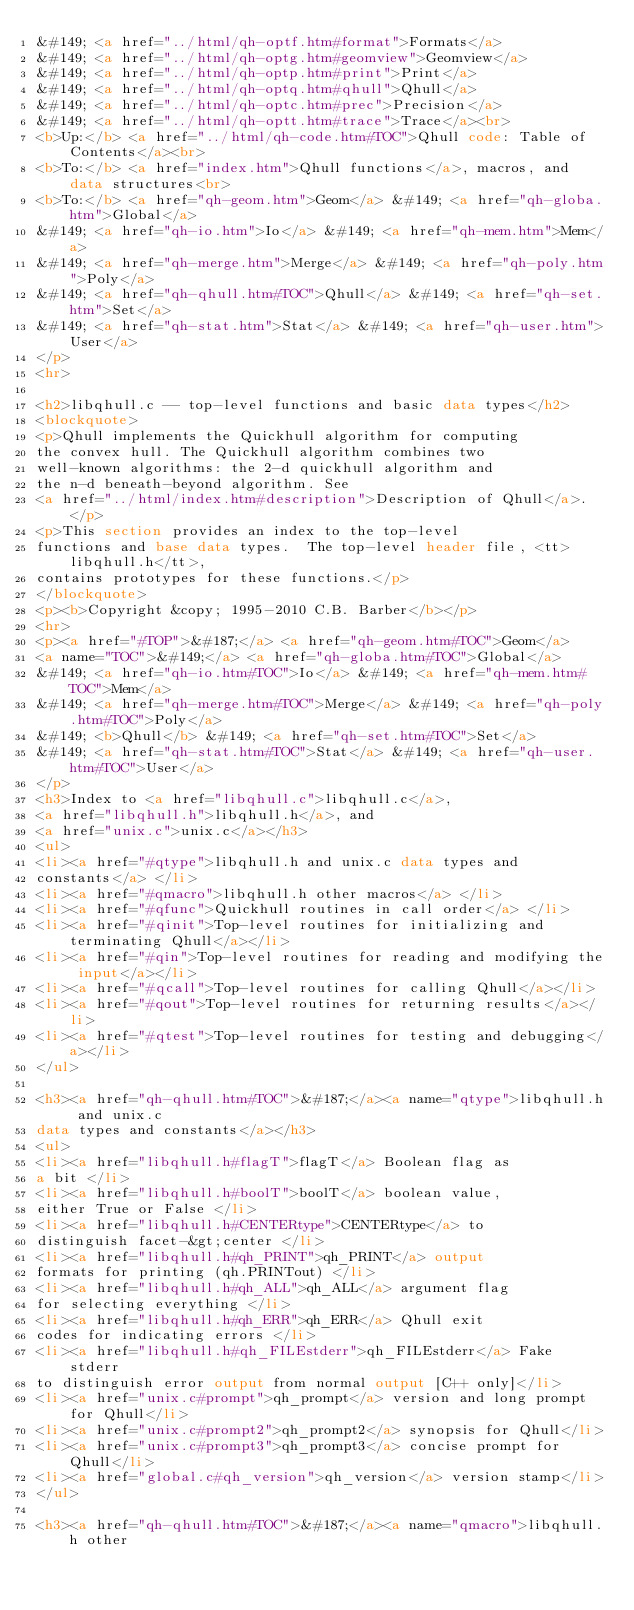<code> <loc_0><loc_0><loc_500><loc_500><_HTML_>&#149; <a href="../html/qh-optf.htm#format">Formats</a>
&#149; <a href="../html/qh-optg.htm#geomview">Geomview</a>
&#149; <a href="../html/qh-optp.htm#print">Print</a>
&#149; <a href="../html/qh-optq.htm#qhull">Qhull</a>
&#149; <a href="../html/qh-optc.htm#prec">Precision</a>
&#149; <a href="../html/qh-optt.htm#trace">Trace</a><br>
<b>Up:</b> <a href="../html/qh-code.htm#TOC">Qhull code: Table of Contents</a><br>
<b>To:</b> <a href="index.htm">Qhull functions</a>, macros, and data structures<br>
<b>To:</b> <a href="qh-geom.htm">Geom</a> &#149; <a href="qh-globa.htm">Global</a>
&#149; <a href="qh-io.htm">Io</a> &#149; <a href="qh-mem.htm">Mem</a>
&#149; <a href="qh-merge.htm">Merge</a> &#149; <a href="qh-poly.htm">Poly</a>
&#149; <a href="qh-qhull.htm#TOC">Qhull</a> &#149; <a href="qh-set.htm">Set</a>
&#149; <a href="qh-stat.htm">Stat</a> &#149; <a href="qh-user.htm">User</a>
</p>
<hr>

<h2>libqhull.c -- top-level functions and basic data types</h2>
<blockquote>
<p>Qhull implements the Quickhull algorithm for computing
the convex hull. The Quickhull algorithm combines two
well-known algorithms: the 2-d quickhull algorithm and
the n-d beneath-beyond algorithm. See
<a href="../html/index.htm#description">Description of Qhull</a>. </p>
<p>This section provides an index to the top-level
functions and base data types.  The top-level header file, <tt>libqhull.h</tt>,
contains prototypes for these functions.</p>
</blockquote>
<p><b>Copyright &copy; 1995-2010 C.B. Barber</b></p>
<hr>
<p><a href="#TOP">&#187;</a> <a href="qh-geom.htm#TOC">Geom</a>
<a name="TOC">&#149;</a> <a href="qh-globa.htm#TOC">Global</a>
&#149; <a href="qh-io.htm#TOC">Io</a> &#149; <a href="qh-mem.htm#TOC">Mem</a>
&#149; <a href="qh-merge.htm#TOC">Merge</a> &#149; <a href="qh-poly.htm#TOC">Poly</a>
&#149; <b>Qhull</b> &#149; <a href="qh-set.htm#TOC">Set</a>
&#149; <a href="qh-stat.htm#TOC">Stat</a> &#149; <a href="qh-user.htm#TOC">User</a>
</p>
<h3>Index to <a href="libqhull.c">libqhull.c</a>,
<a href="libqhull.h">libqhull.h</a>, and
<a href="unix.c">unix.c</a></h3>
<ul>
<li><a href="#qtype">libqhull.h and unix.c data types and
constants</a> </li>
<li><a href="#qmacro">libqhull.h other macros</a> </li>
<li><a href="#qfunc">Quickhull routines in call order</a> </li>
<li><a href="#qinit">Top-level routines for initializing and terminating Qhull</a></li>
<li><a href="#qin">Top-level routines for reading and modifying the input</a></li>
<li><a href="#qcall">Top-level routines for calling Qhull</a></li>
<li><a href="#qout">Top-level routines for returning results</a></li>
<li><a href="#qtest">Top-level routines for testing and debugging</a></li>
</ul>

<h3><a href="qh-qhull.htm#TOC">&#187;</a><a name="qtype">libqhull.h and unix.c
data types and constants</a></h3>
<ul>
<li><a href="libqhull.h#flagT">flagT</a> Boolean flag as
a bit </li>
<li><a href="libqhull.h#boolT">boolT</a> boolean value,
either True or False </li>
<li><a href="libqhull.h#CENTERtype">CENTERtype</a> to
distinguish facet-&gt;center </li>
<li><a href="libqhull.h#qh_PRINT">qh_PRINT</a> output
formats for printing (qh.PRINTout) </li>
<li><a href="libqhull.h#qh_ALL">qh_ALL</a> argument flag
for selecting everything </li>
<li><a href="libqhull.h#qh_ERR">qh_ERR</a> Qhull exit
codes for indicating errors </li>
<li><a href="libqhull.h#qh_FILEstderr">qh_FILEstderr</a> Fake stderr
to distinguish error output from normal output [C++ only]</li>
<li><a href="unix.c#prompt">qh_prompt</a> version and long prompt for Qhull</li>
<li><a href="unix.c#prompt2">qh_prompt2</a> synopsis for Qhull</li>
<li><a href="unix.c#prompt3">qh_prompt3</a> concise prompt for Qhull</li>
<li><a href="global.c#qh_version">qh_version</a> version stamp</li>
</ul>

<h3><a href="qh-qhull.htm#TOC">&#187;</a><a name="qmacro">libqhull.h other</code> 